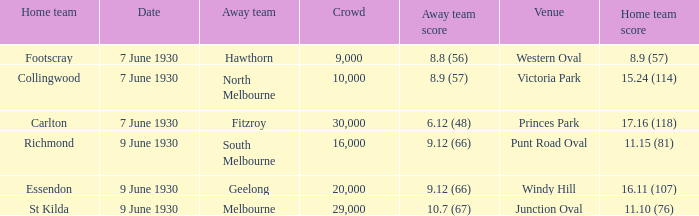What is the average crowd size when North Melbourne is the away team? 10000.0. 